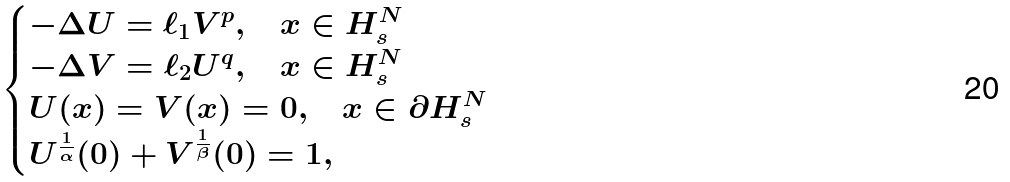<formula> <loc_0><loc_0><loc_500><loc_500>\begin{cases} - \Delta U = \ell _ { 1 } V ^ { p } , \quad x \in H ^ { N } _ { s } \\ - \Delta V = \ell _ { 2 } U ^ { q } , \quad x \in H ^ { N } _ { s } \\ U ( x ) = V ( x ) = 0 , \quad x \in \partial H ^ { N } _ { s } \\ U ^ { \frac { 1 } { \alpha } } ( 0 ) + V ^ { \frac { 1 } { \beta } } ( 0 ) = 1 , \end{cases}</formula> 